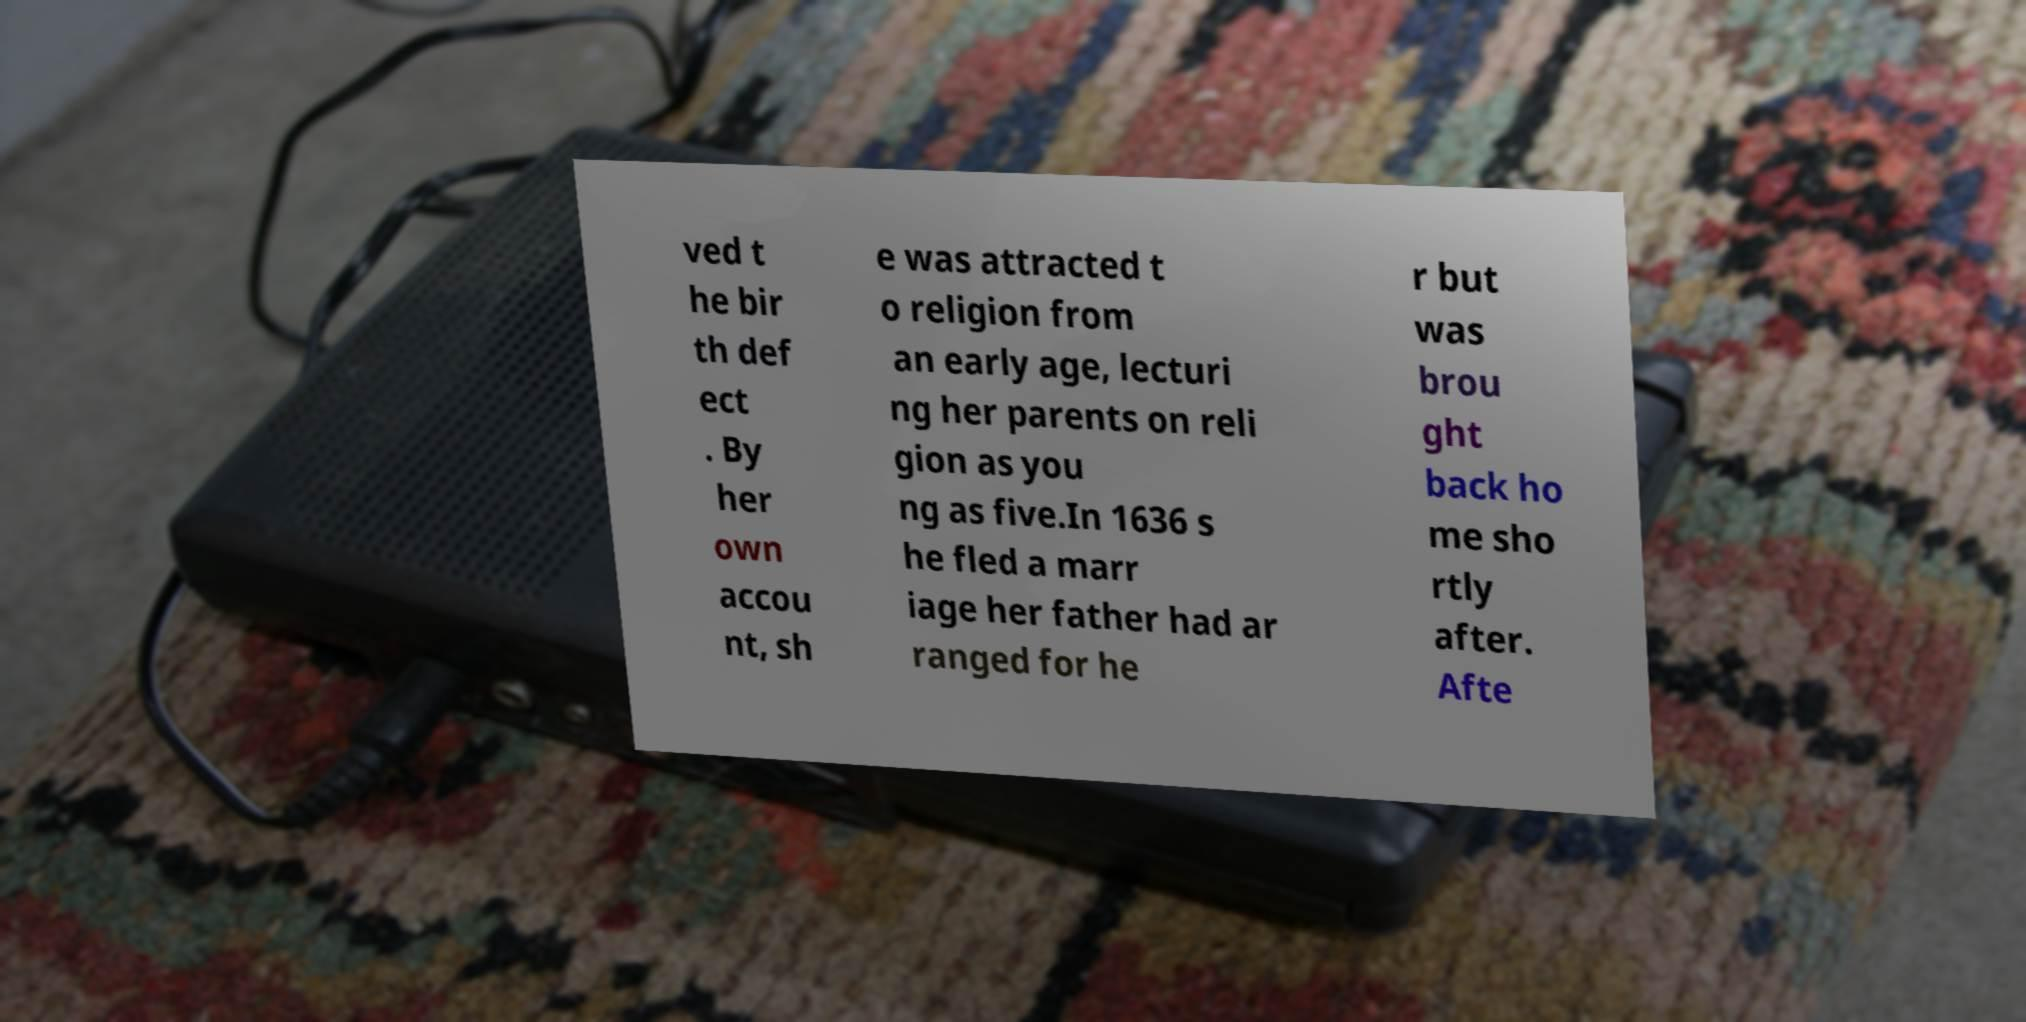Please read and relay the text visible in this image. What does it say? ved t he bir th def ect . By her own accou nt, sh e was attracted t o religion from an early age, lecturi ng her parents on reli gion as you ng as five.In 1636 s he fled a marr iage her father had ar ranged for he r but was brou ght back ho me sho rtly after. Afte 